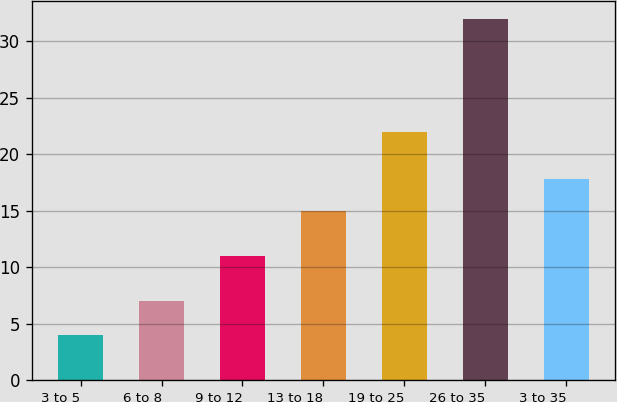Convert chart to OTSL. <chart><loc_0><loc_0><loc_500><loc_500><bar_chart><fcel>3 to 5<fcel>6 to 8<fcel>9 to 12<fcel>13 to 18<fcel>19 to 25<fcel>26 to 35<fcel>3 to 35<nl><fcel>4<fcel>7<fcel>11<fcel>15<fcel>22<fcel>32<fcel>17.8<nl></chart> 